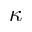<formula> <loc_0><loc_0><loc_500><loc_500>\kappa</formula> 